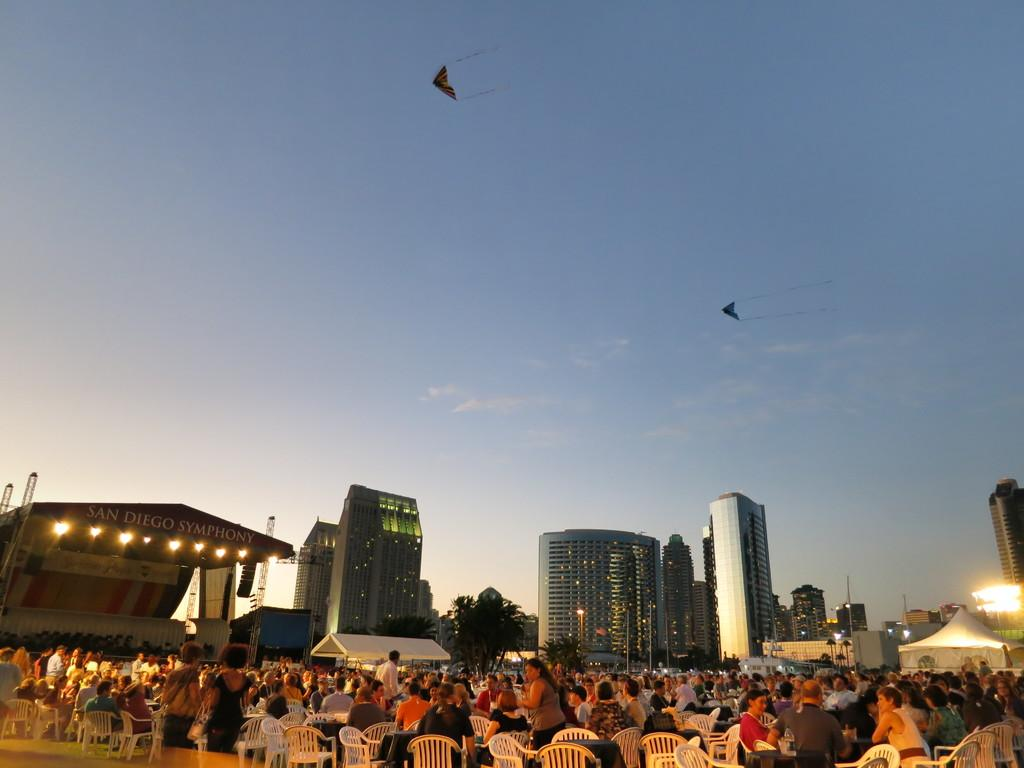What are the people in the image doing? The people in the image are sitting in chairs. What can be seen in the distance behind the people? There are buildings in the background. What is happening in the sky in the image? There are two objects flying in the sky. What type of wax is being used to create the flight path for the cart in the image? There is no wax, flight path, or cart present in the image. 